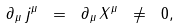Convert formula to latex. <formula><loc_0><loc_0><loc_500><loc_500>\partial _ { \mu } \, j ^ { \mu } \ = \ \partial _ { \mu } \, X ^ { \mu } \ \neq \ 0 ,</formula> 